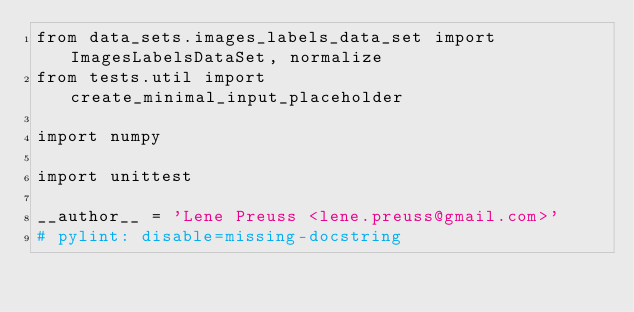Convert code to text. <code><loc_0><loc_0><loc_500><loc_500><_Python_>from data_sets.images_labels_data_set import ImagesLabelsDataSet, normalize
from tests.util import create_minimal_input_placeholder

import numpy

import unittest

__author__ = 'Lene Preuss <lene.preuss@gmail.com>'
# pylint: disable=missing-docstring
</code> 